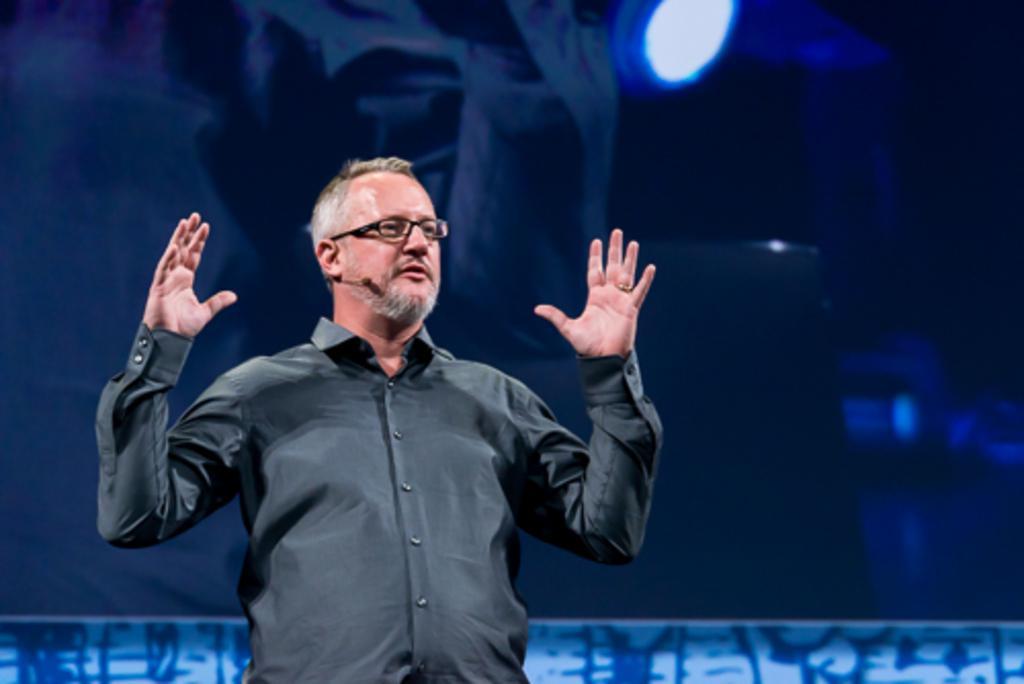Can you describe this image briefly? In this picture I can see a man with spectacles, and there is blur background. 